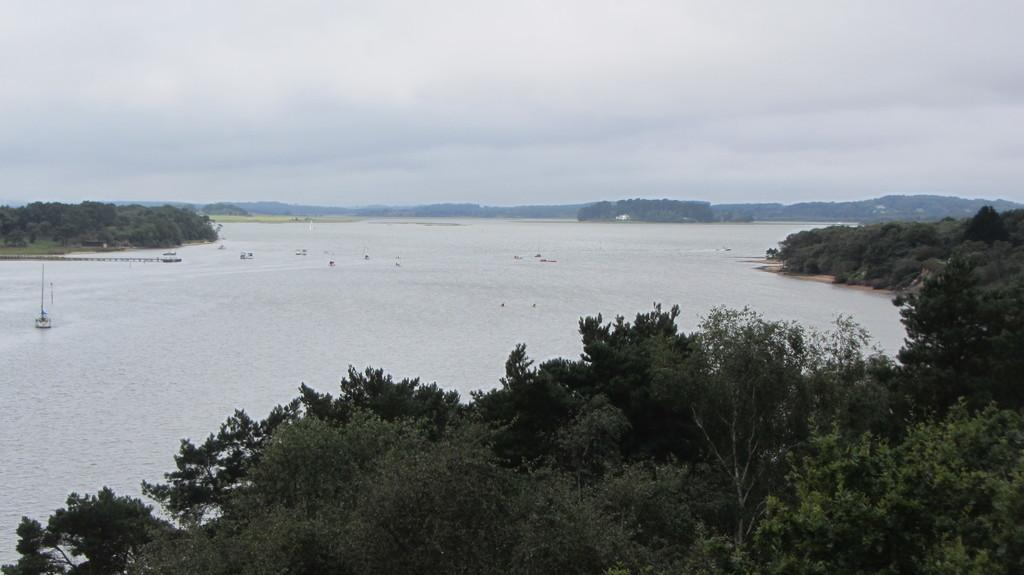What type of vegetation can be seen in the image? There are trees in the image. What is present in the water in the image? There are boats in the water in the image. What can be seen in the sky in the image? There are clouds in the sky in the image. What geographical feature is visible in the image? There is a hill in the image. What type of string is attached to the hill in the image? There is no string present in the image; it only features trees, boats, clouds, and a hill. 